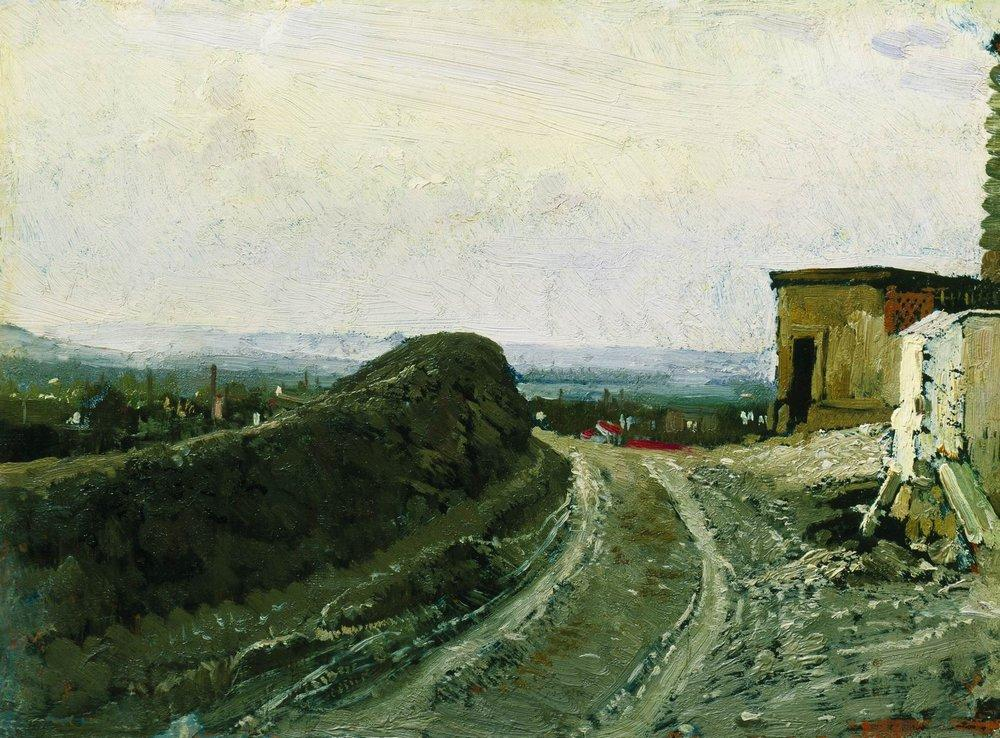What might the red flag on the building signify in this painting? The red flag in the painting might symbolize a point of interest or significance within the rural community depicted. It could indicate a meeting place, a landmark, or even a festive or ceremonial site. In artistic terms, it also serves to draw the viewer’s eye and provide a spot of vibrant color contrast against the predominantly green and brown landscape. 